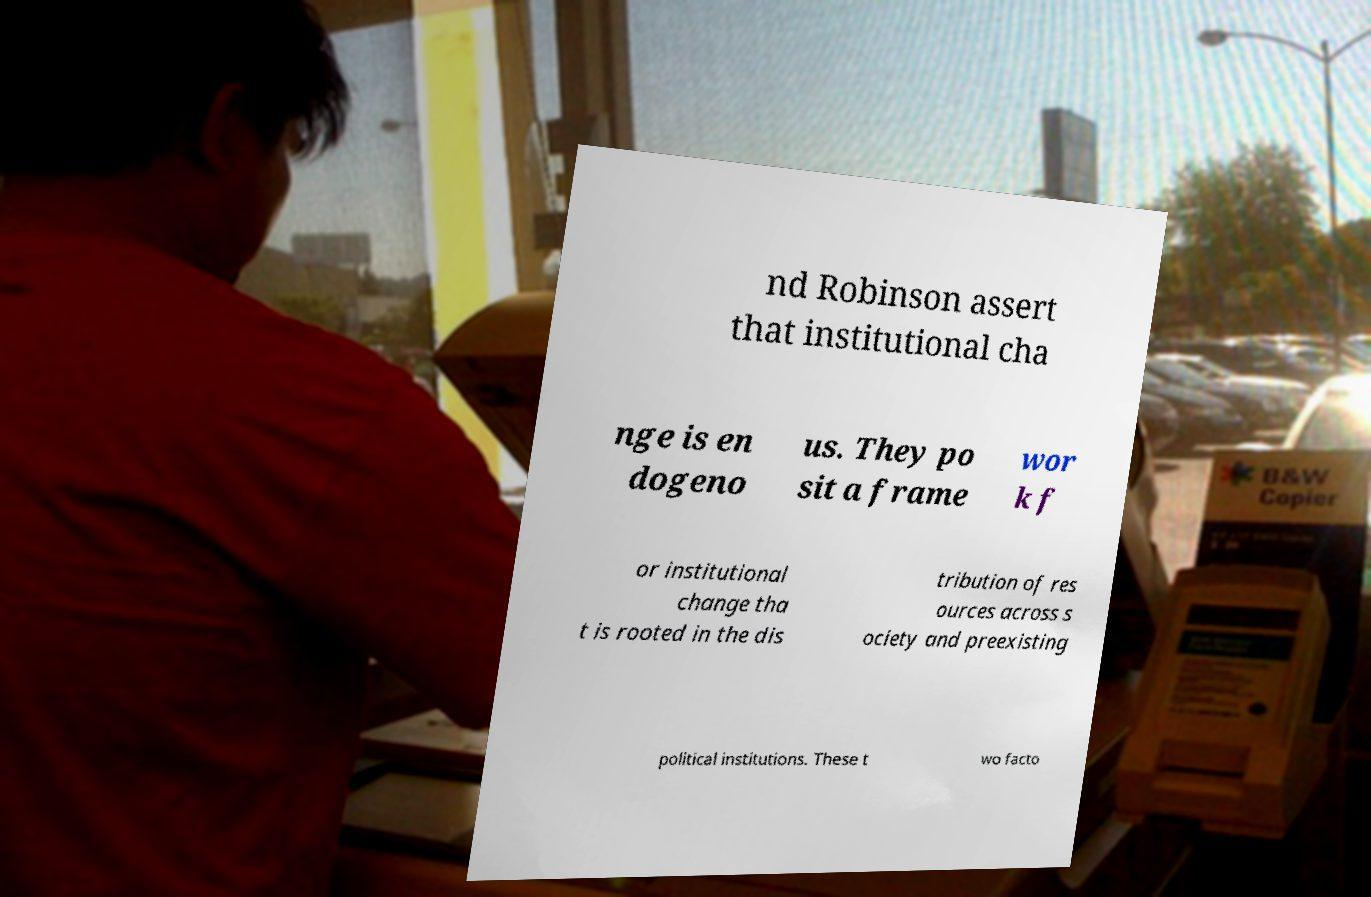There's text embedded in this image that I need extracted. Can you transcribe it verbatim? nd Robinson assert that institutional cha nge is en dogeno us. They po sit a frame wor k f or institutional change tha t is rooted in the dis tribution of res ources across s ociety and preexisting political institutions. These t wo facto 